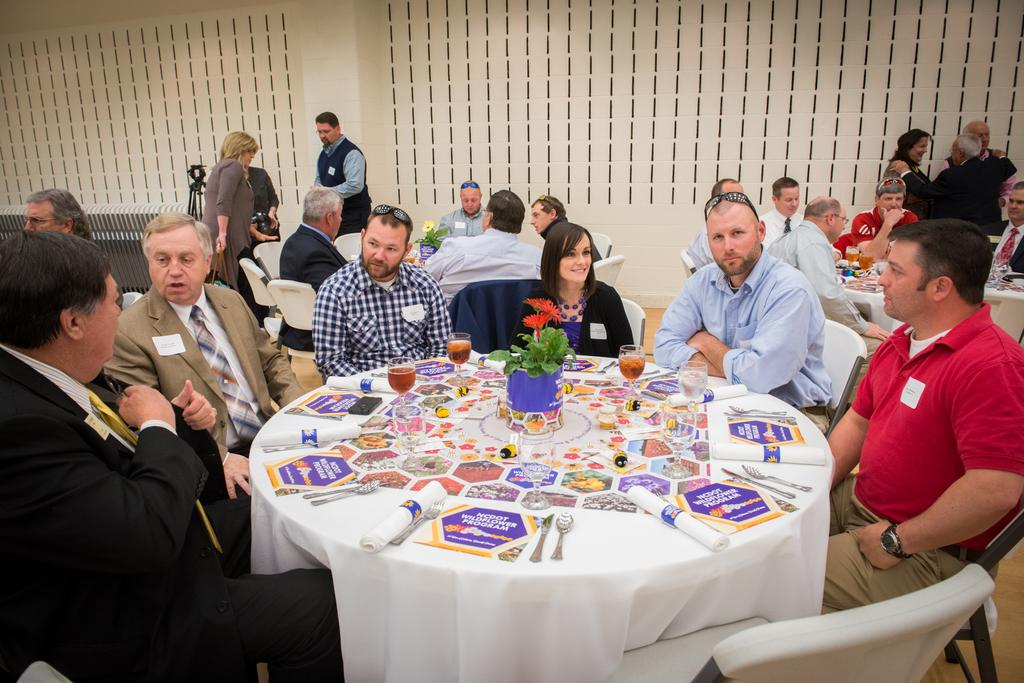Who or what can be seen in the image? There are people in the image. How are the people arranged in the image? The people are sitting in groups. Where are the groups of people located? The groups are around tables. What are the people doing in the image? The people are discussing among themselves. What type of throne is present in the image? There is no throne present in the image; it features people sitting around tables. How many wrists can be seen in the image? The number of wrists cannot be determined from the image, as it only shows people sitting around tables and discussing. 